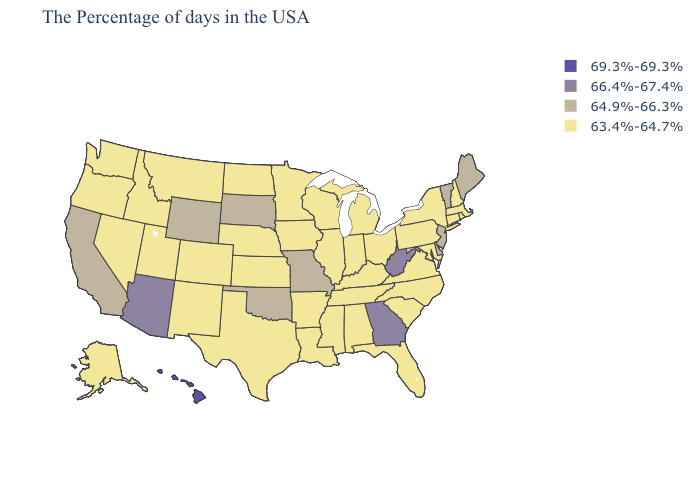Does the first symbol in the legend represent the smallest category?
Give a very brief answer. No. Does Iowa have the lowest value in the USA?
Answer briefly. Yes. Among the states that border Indiana , which have the lowest value?
Be succinct. Ohio, Michigan, Kentucky, Illinois. What is the value of Tennessee?
Concise answer only. 63.4%-64.7%. What is the highest value in states that border New Hampshire?
Quick response, please. 64.9%-66.3%. How many symbols are there in the legend?
Give a very brief answer. 4. Among the states that border Wyoming , which have the lowest value?
Concise answer only. Nebraska, Colorado, Utah, Montana, Idaho. What is the highest value in the MidWest ?
Write a very short answer. 64.9%-66.3%. Does the map have missing data?
Quick response, please. No. What is the highest value in the USA?
Short answer required. 69.3%-69.3%. Name the states that have a value in the range 64.9%-66.3%?
Give a very brief answer. Maine, Vermont, New Jersey, Delaware, Missouri, Oklahoma, South Dakota, Wyoming, California. Does Kentucky have the same value as Georgia?
Short answer required. No. Name the states that have a value in the range 69.3%-69.3%?
Short answer required. Hawaii. What is the value of California?
Give a very brief answer. 64.9%-66.3%. Does the map have missing data?
Answer briefly. No. 